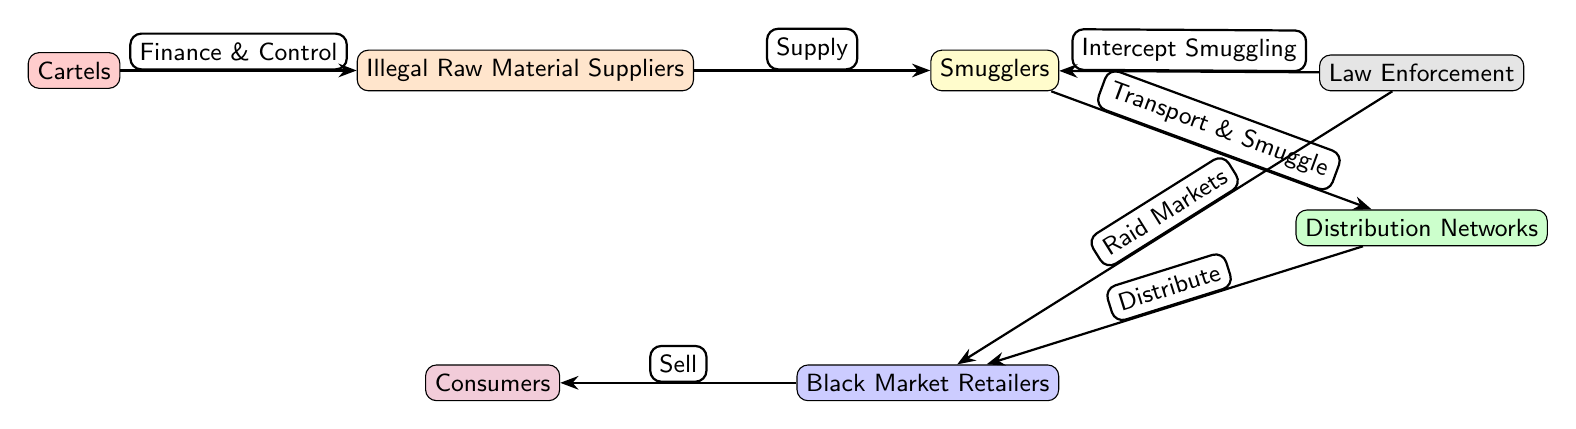What is the first node in the food chain? The first node in the food chain is labeled "Cartels." It is positioned at the beginning and represents the organized crime syndicate that initiates the supply chain.
Answer: Cartels How many primary nodes are represented in the diagram? There are six primary nodes in the diagram: Cartels, Illegal Raw Material Suppliers, Smugglers, Distribution Networks, Black Market Retailers, and Consumers. Counting these nodes gives a total of six.
Answer: Six What type of edge connects Cartels to Illegal Raw Material Suppliers? The edge connecting Cartels to Illegal Raw Material Suppliers is labeled "Finance & Control." This indicates the method of influence or interaction between the two nodes.
Answer: Finance & Control What activity connects Smugglers to Distribution Networks? The activity connecting Smugglers to Distribution Networks is indicated by the edge labeled "Transport & Smuggle." This shows the action that takes place between these two entities.
Answer: Transport & Smuggle Which node receives goods from Distribution Networks? The node that receives goods from Distribution Networks is labeled "Black Market Retailers." The flow of goods moves from Distribution Networks directly to this node.
Answer: Black Market Retailers What action does Law Enforcement take against Smugglers? Law Enforcement takes the action labeled "Intercept Smuggling" against Smugglers. This represents the enforcement measures aimed at disrupting the illegal activities.
Answer: Intercept Smuggling How do Black Market Retailers sell to Consumers? Black Market Retailers sell to Consumers through the labeled action "Sell." This indicates the final transaction stage in the supply chain depicted in the diagram.
Answer: Sell How do Laws impact Black Market Retailers? Laws impact Black Market Retailers by enabling Law Enforcement to "Raid Markets," thus disrupting their operational activities significantly. This connection shows the influence of legal regulations on the illicit market.
Answer: Raid Markets What role do Distribution Networks play in the flow from Smugglers to Black Market Retailers? Distribution Networks are critical in the flow as they facilitate the transfer of goods, functioning as the intermediary that connects Smugglers to Black Market Retailers. This position in the diagram highlights their essential role in the supply chain.
Answer: Facilitate transfer 